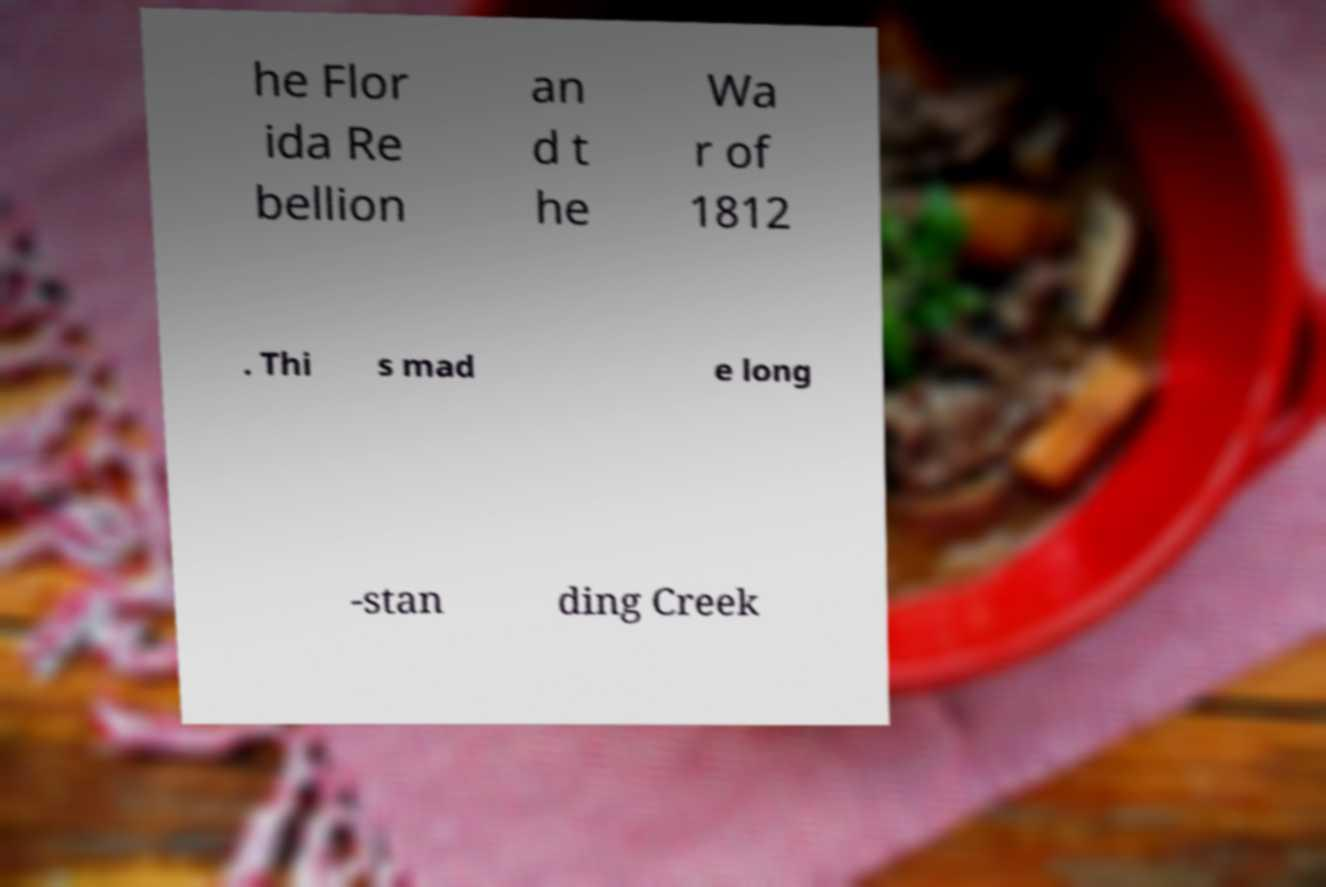There's text embedded in this image that I need extracted. Can you transcribe it verbatim? he Flor ida Re bellion an d t he Wa r of 1812 . Thi s mad e long -stan ding Creek 